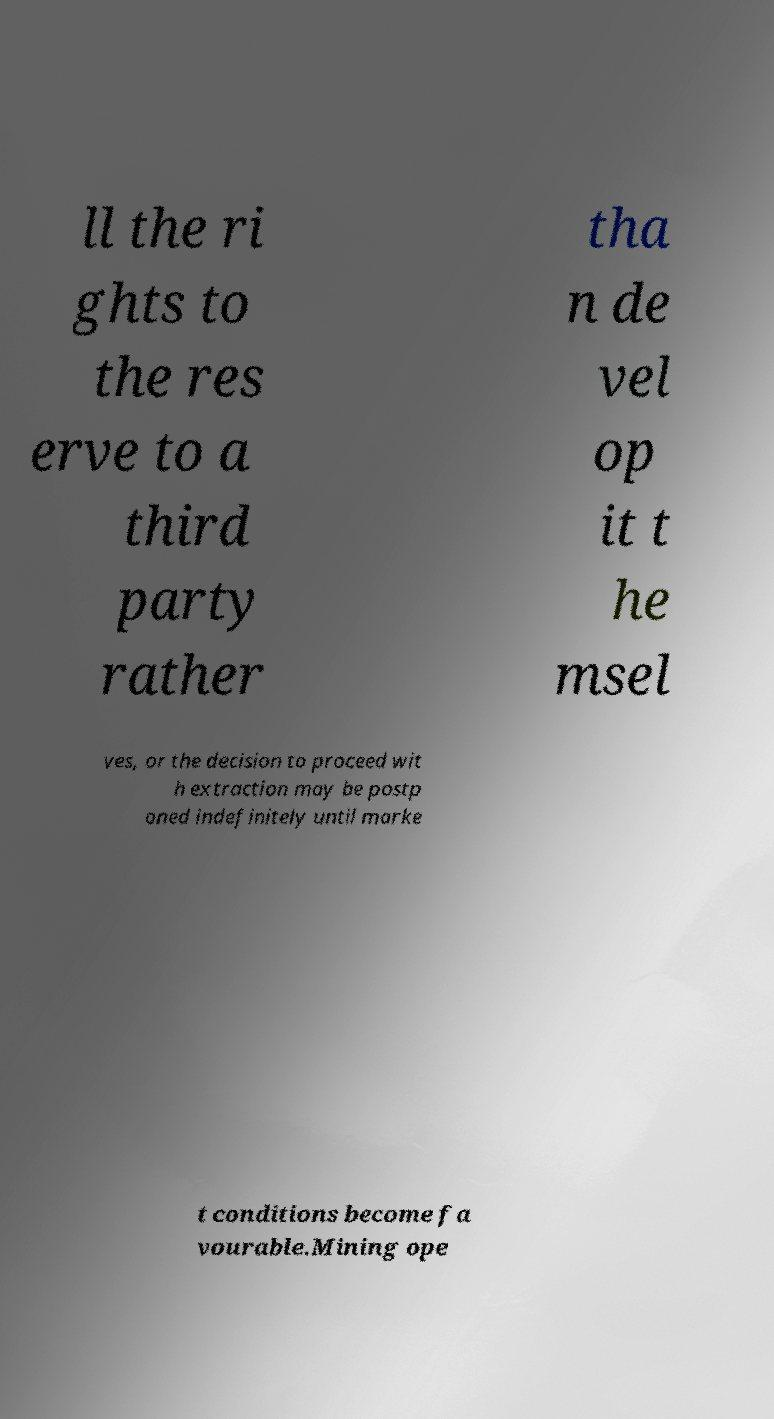I need the written content from this picture converted into text. Can you do that? ll the ri ghts to the res erve to a third party rather tha n de vel op it t he msel ves, or the decision to proceed wit h extraction may be postp oned indefinitely until marke t conditions become fa vourable.Mining ope 